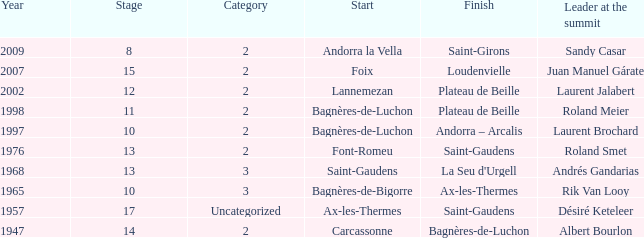Supply the conclusion for a stage greater than 1 Saint-Gaudens. 